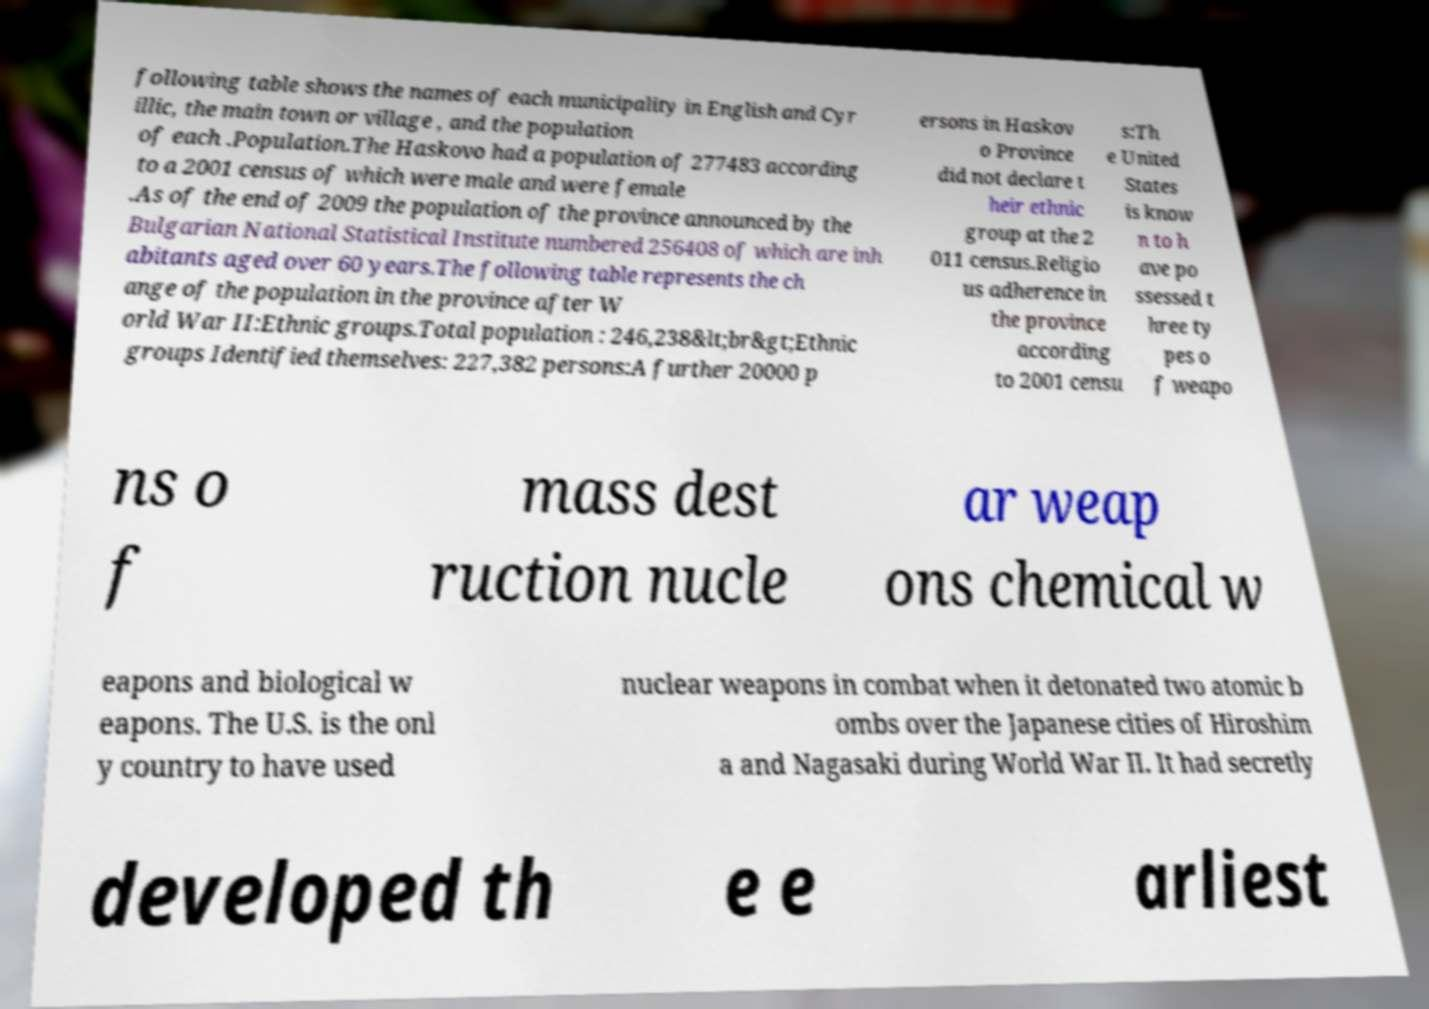Please read and relay the text visible in this image. What does it say? following table shows the names of each municipality in English and Cyr illic, the main town or village , and the population of each .Population.The Haskovo had a population of 277483 according to a 2001 census of which were male and were female .As of the end of 2009 the population of the province announced by the Bulgarian National Statistical Institute numbered 256408 of which are inh abitants aged over 60 years.The following table represents the ch ange of the population in the province after W orld War II:Ethnic groups.Total population : 246,238&lt;br&gt;Ethnic groups Identified themselves: 227,382 persons:A further 20000 p ersons in Haskov o Province did not declare t heir ethnic group at the 2 011 census.Religio us adherence in the province according to 2001 censu s:Th e United States is know n to h ave po ssessed t hree ty pes o f weapo ns o f mass dest ruction nucle ar weap ons chemical w eapons and biological w eapons. The U.S. is the onl y country to have used nuclear weapons in combat when it detonated two atomic b ombs over the Japanese cities of Hiroshim a and Nagasaki during World War II. It had secretly developed th e e arliest 